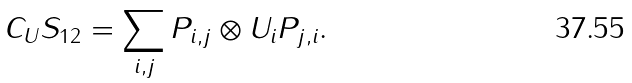Convert formula to latex. <formula><loc_0><loc_0><loc_500><loc_500>C _ { U } S _ { 1 2 } = \sum _ { i , j } P _ { i , j } \otimes U _ { i } P _ { j , i } .</formula> 